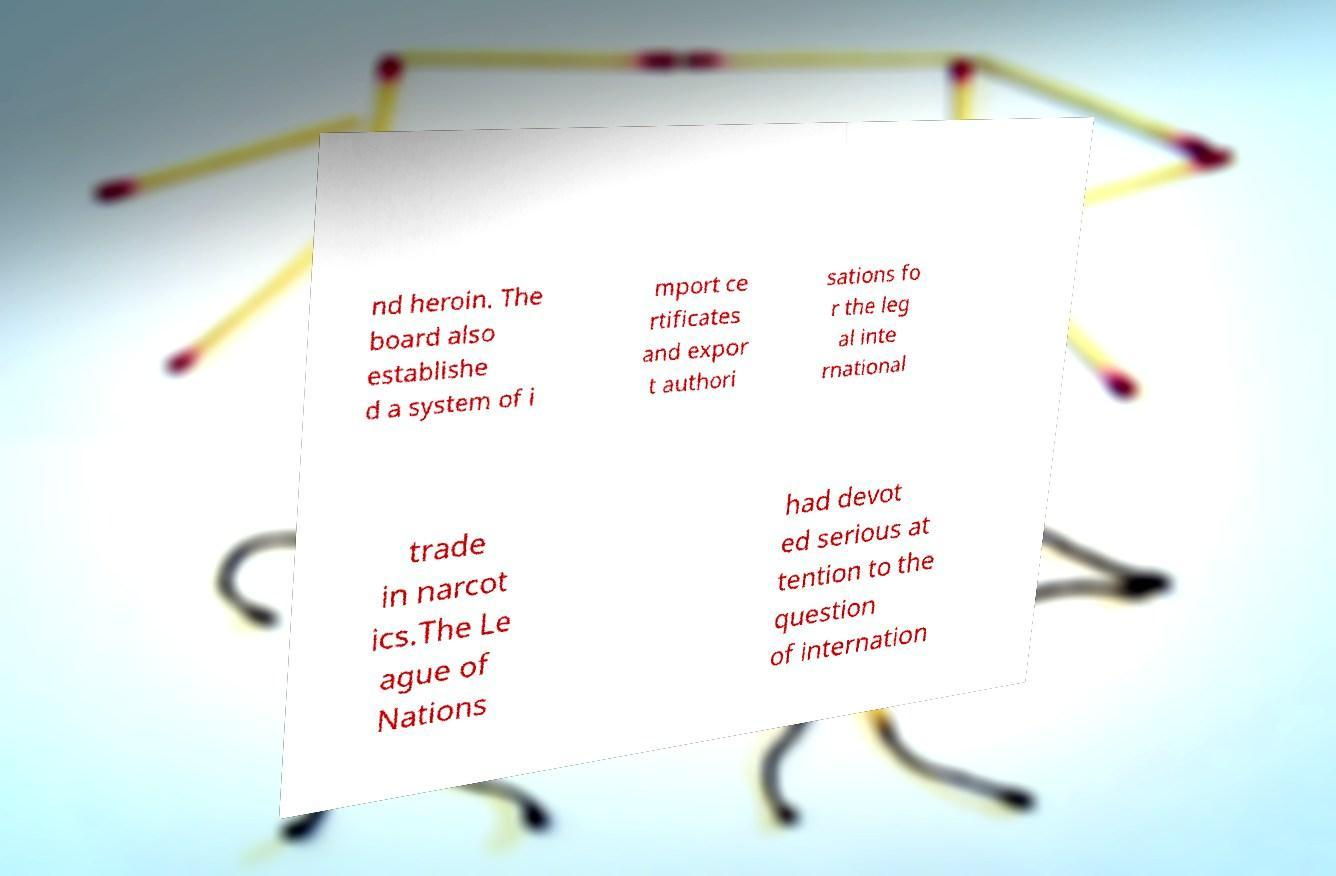Could you assist in decoding the text presented in this image and type it out clearly? nd heroin. The board also establishe d a system of i mport ce rtificates and expor t authori sations fo r the leg al inte rnational trade in narcot ics.The Le ague of Nations had devot ed serious at tention to the question of internation 